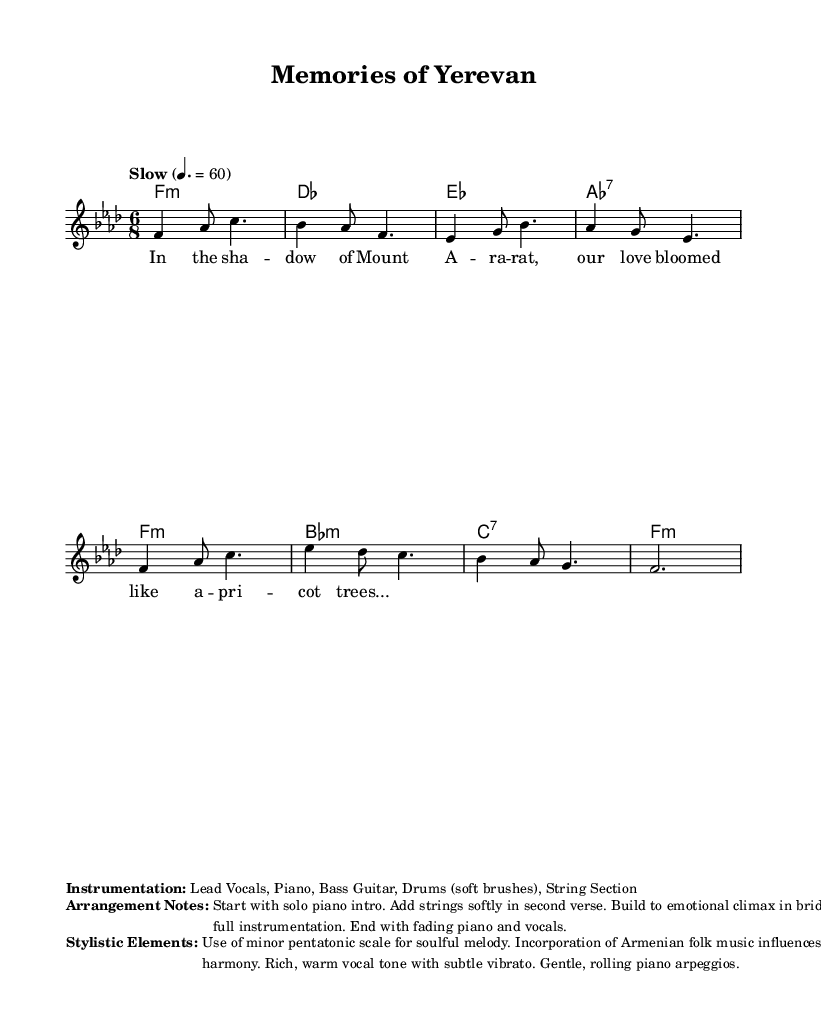What is the key signature of this music? The key signature is indicated at the beginning of the sheet music. It shows one flat, which corresponds to F minor.
Answer: F minor What is the time signature of this piece? The time signature is shown next to the key signature. It displays a 6 over an 8, indicating 6/8 time.
Answer: 6/8 What is the tempo marking for this piece? The tempo is indicated in the score, marked as "Slow" with a tempo of 4 beats per minute set to 60.
Answer: Slow How many measures are there in the melody line? By counting the distinct segments in the melody section, we find a total of eight measures.
Answer: Eight What instrumentation is used in this piece? The instrumentation is described in a marked section of the score, indicating Lead Vocals, Piano, Bass Guitar, Drums (soft brushes), and String Section.
Answer: Lead Vocals, Piano, Bass Guitar, Drums, String Section What stylistic elements are highlighted in this score? The score includes a description of stylistic elements, identifying the use of a minor pentatonic scale, Armenian folk music influences, rich vocal tones, and gentle piano arpeggios.
Answer: Minor pentatonic scale, Armenian folk music influences What is the emotional climax of this piece characterized by? The arrangement notes indicate that the emotional climax occurs in the bridge, where full instrumentation is used to enhance the emotional build-up.
Answer: Full instrumentation in the bridge 